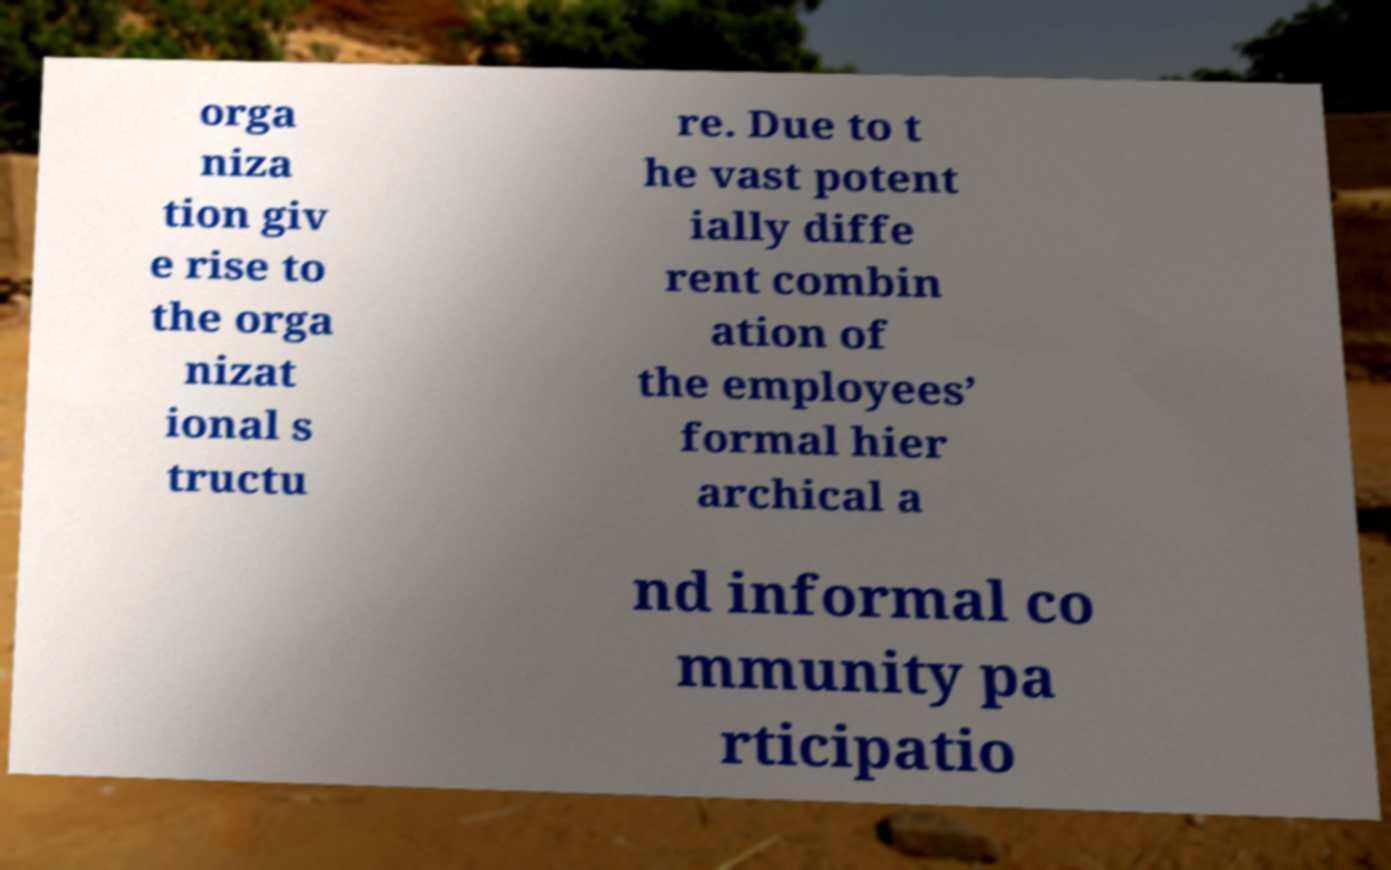Please read and relay the text visible in this image. What does it say? orga niza tion giv e rise to the orga nizat ional s tructu re. Due to t he vast potent ially diffe rent combin ation of the employees’ formal hier archical a nd informal co mmunity pa rticipatio 